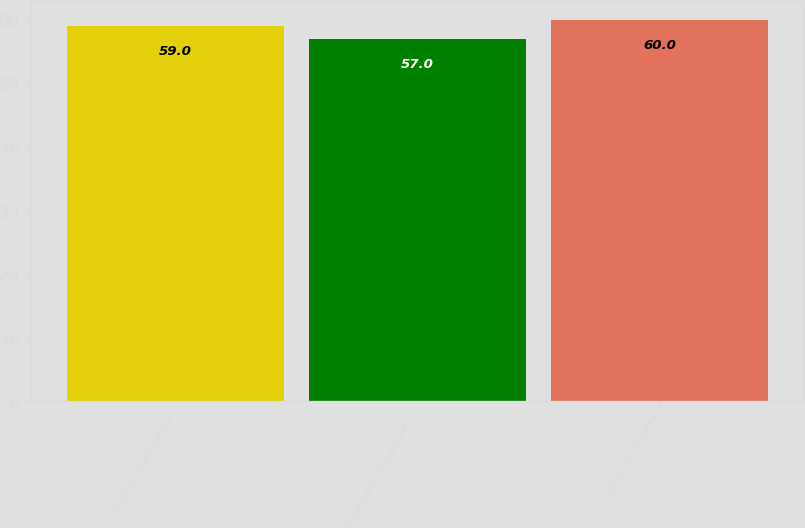<chart> <loc_0><loc_0><loc_500><loc_500><bar_chart><fcel>Consolidated Statements of<fcel>Consolidated Balance Sheets -<fcel>Notes to Consolidated<nl><fcel>59<fcel>57<fcel>60<nl></chart> 